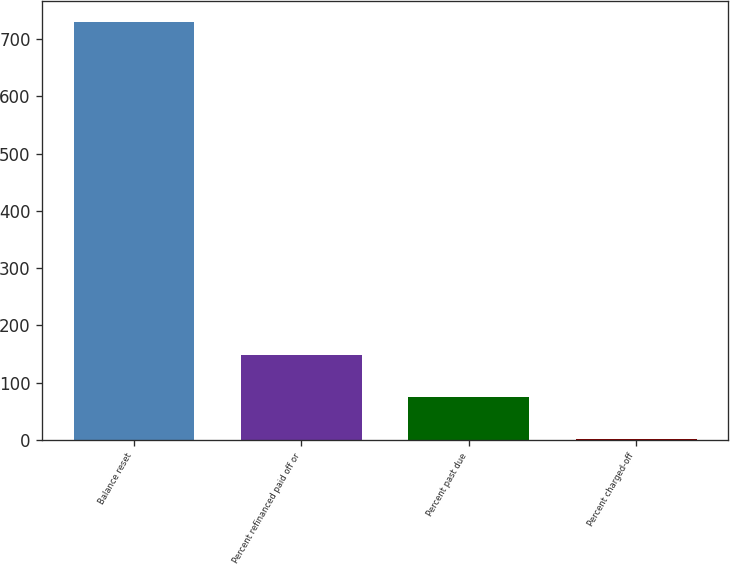<chart> <loc_0><loc_0><loc_500><loc_500><bar_chart><fcel>Balance reset<fcel>Percent refinanced paid off or<fcel>Percent past due<fcel>Percent charged-off<nl><fcel>730<fcel>147.6<fcel>74.8<fcel>2<nl></chart> 